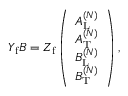Convert formula to latex. <formula><loc_0><loc_0><loc_500><loc_500>\begin{array} { r } { Y _ { f } B = Z _ { f } \left ( \begin{array} { l } { A _ { L } ^ { ( N ) } } \\ { A _ { T } ^ { ( N ) } } \\ { B _ { L } ^ { ( N ) } } \\ { B _ { T } ^ { ( N ) } } \end{array} \right ) , } \end{array}</formula> 